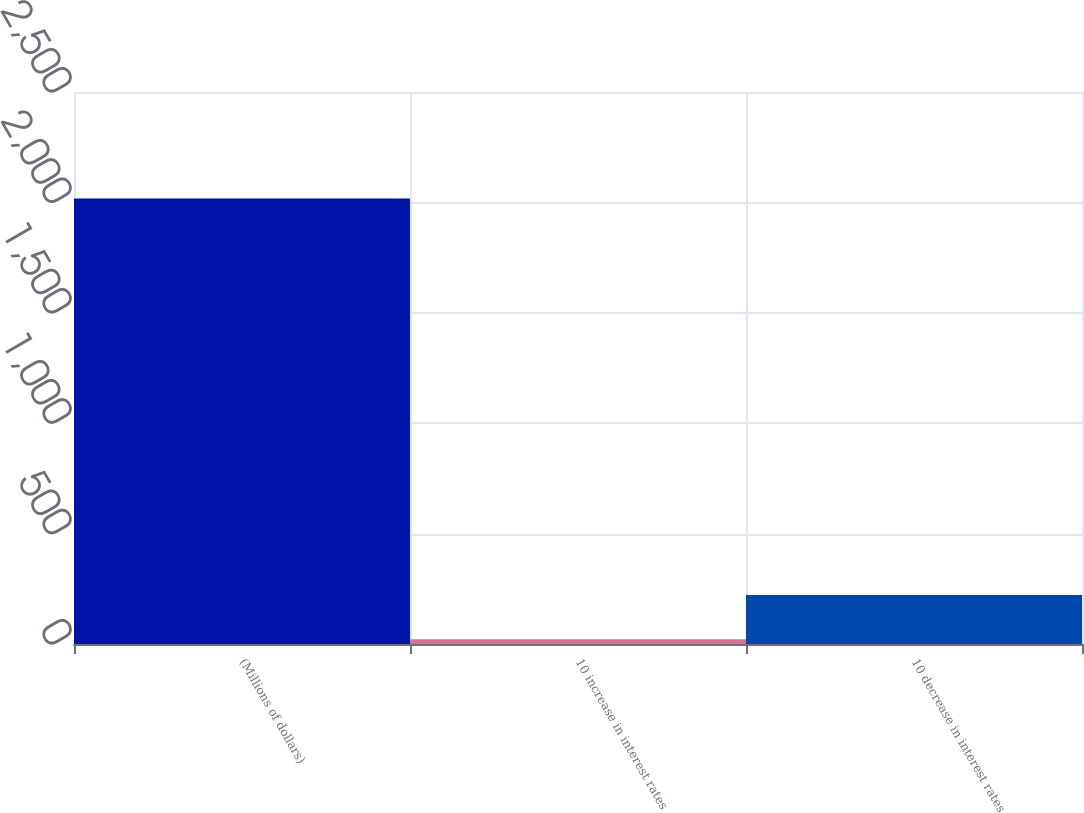Convert chart. <chart><loc_0><loc_0><loc_500><loc_500><bar_chart><fcel>(Millions of dollars)<fcel>10 increase in interest rates<fcel>10 decrease in interest rates<nl><fcel>2018<fcel>22<fcel>221.6<nl></chart> 